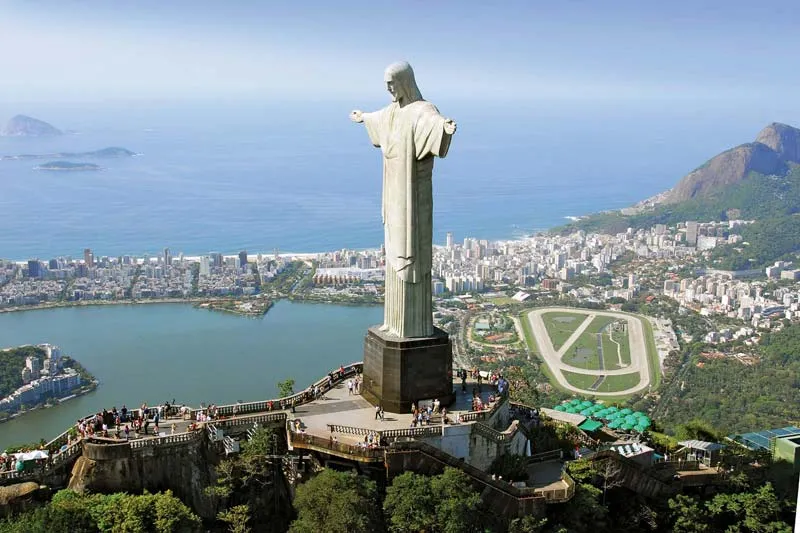Can you tell me about the construction methods used for the statue? Certainly! Constructing the Christ the Redeemer statue was an extraordinary feat for its time. It was primarily designed by Brazilian engineer Heitor da Silva Costa and sculpted by French sculptor Paul Landowski. The outer layers consist of soapstone tiles, which are both weather-resistant and malleable, making them ideal for the statue's intricate details. The internal structure is made of reinforced concrete, ensuring strength and durability. Interestingly, these materials had to be transported up the mountain by railway before construction could begin. The process took nine years, from 1922 to 1931, reflecting the dedication and effort behind this monumental icon. 